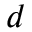<formula> <loc_0><loc_0><loc_500><loc_500>d</formula> 